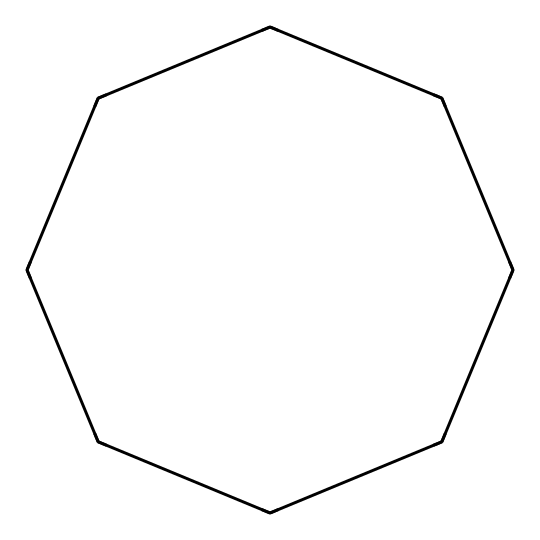what is the name of the chemical represented by this SMILES? The SMILES format given corresponds to a cyclic alkane with eight carbon atoms, which is known as cyclooctane.
Answer: cyclooctane how many carbon atoms are present in this chemical? By analyzing the SMILES notation, we see the 'C's indicating carbon atoms. As there are eight 'C's in the sequence, the molecule has eight carbon atoms.
Answer: eight how many hydrogen atoms are in cyclooctane? Cycloalkanes follow the general formula CnH2n. Given that this molecule has 8 carbon atoms (n=8), we can calculate the number of hydrogen atoms as 2*8 = 16.
Answer: sixteen is this compound branched or unbranched? The structure represented shows that all carbon atoms are arranged in a ring with no branches. Therefore, the compound is unbranched.
Answer: unbranched what type of hydrocarbon is cyclooctane classified as? Cyclooctane is classified as a cycloalkane due to its cyclic structure and only single bonds between carbon atoms.
Answer: cycloalkane how does the cyclic structure affect the boiling point of cyclooctane compared to linear alkanes? Cycloalkanes generally have higher boiling points than linear alkanes of similar molecular weight due to ring strain and different packing efficiencies; cyclooctane's cyclic structure leads to more compact packing and stronger intermolecular forces.
Answer: higher boiling point what is one application of cyclooctane in automotive lubricants? Cyclooctane's properties make it useful as a base fluid in some automotive lubricants, where it helps to provide stability and lubrication under high temperatures.
Answer: base fluid in automotive lubricants 